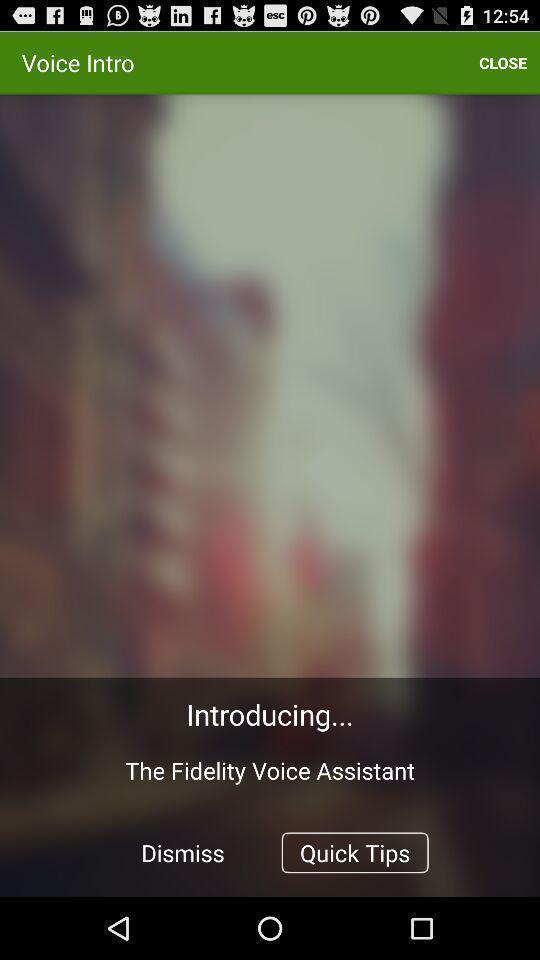Provide a description of this screenshot. Quick tips in introducing the voice assistant. 